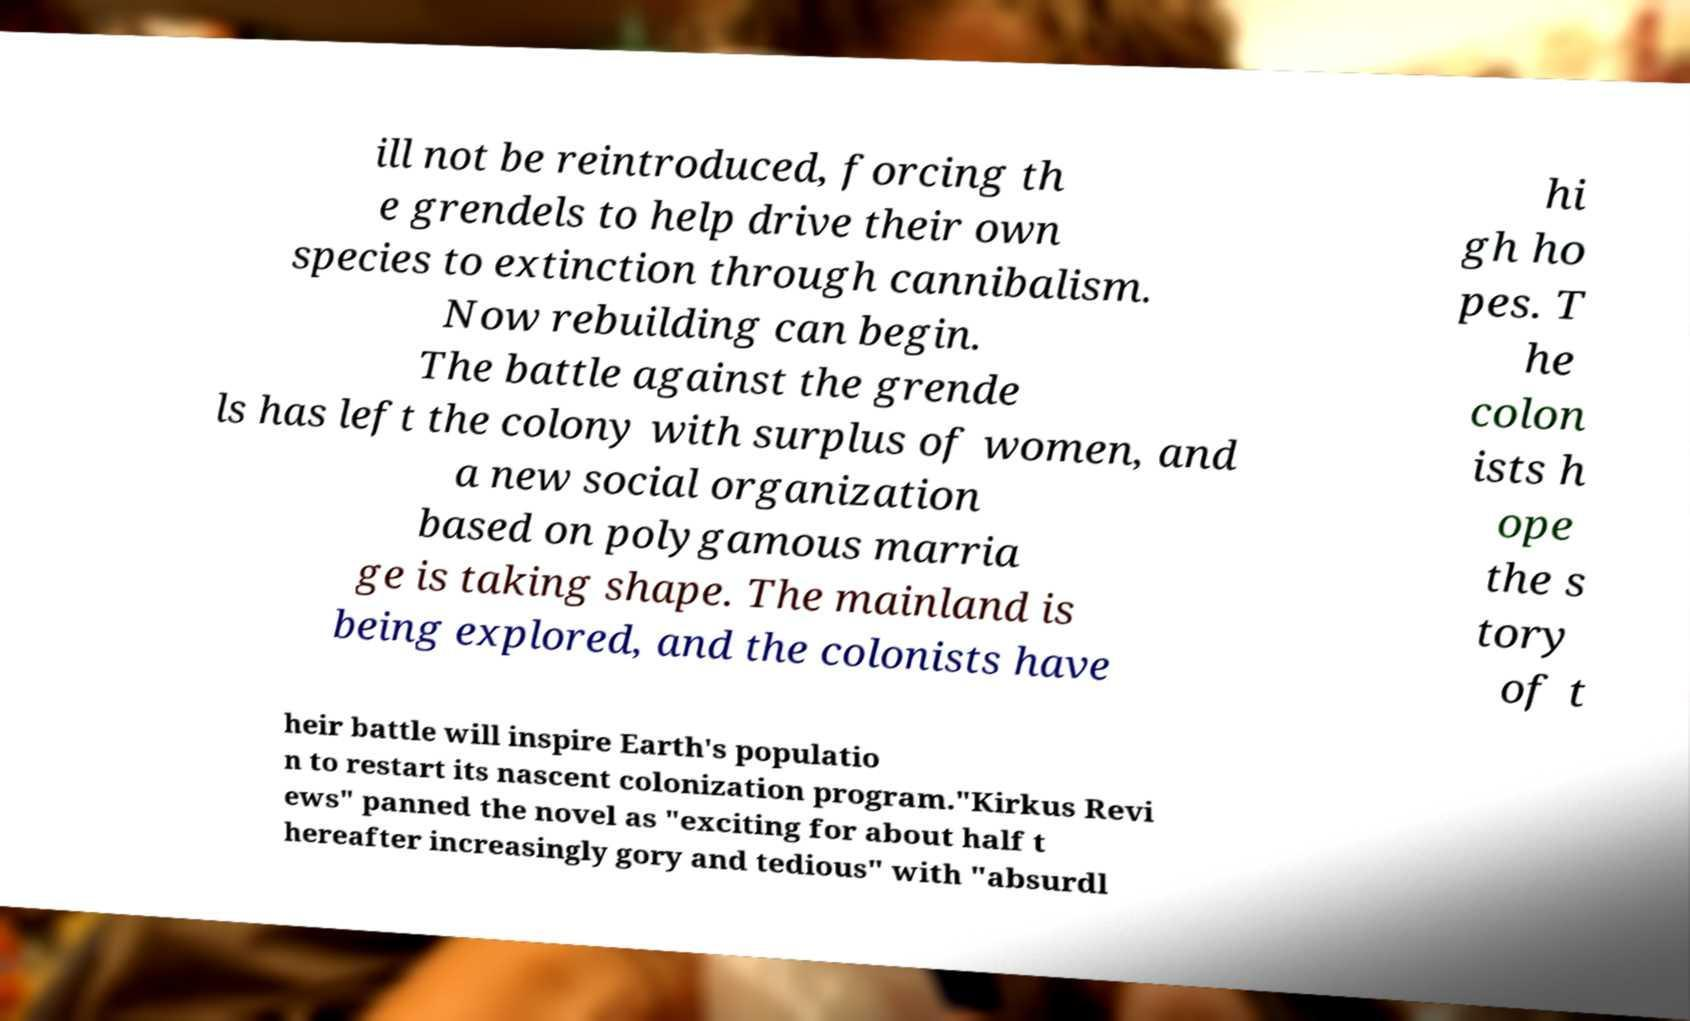Could you assist in decoding the text presented in this image and type it out clearly? ill not be reintroduced, forcing th e grendels to help drive their own species to extinction through cannibalism. Now rebuilding can begin. The battle against the grende ls has left the colony with surplus of women, and a new social organization based on polygamous marria ge is taking shape. The mainland is being explored, and the colonists have hi gh ho pes. T he colon ists h ope the s tory of t heir battle will inspire Earth's populatio n to restart its nascent colonization program."Kirkus Revi ews" panned the novel as "exciting for about half t hereafter increasingly gory and tedious" with "absurdl 